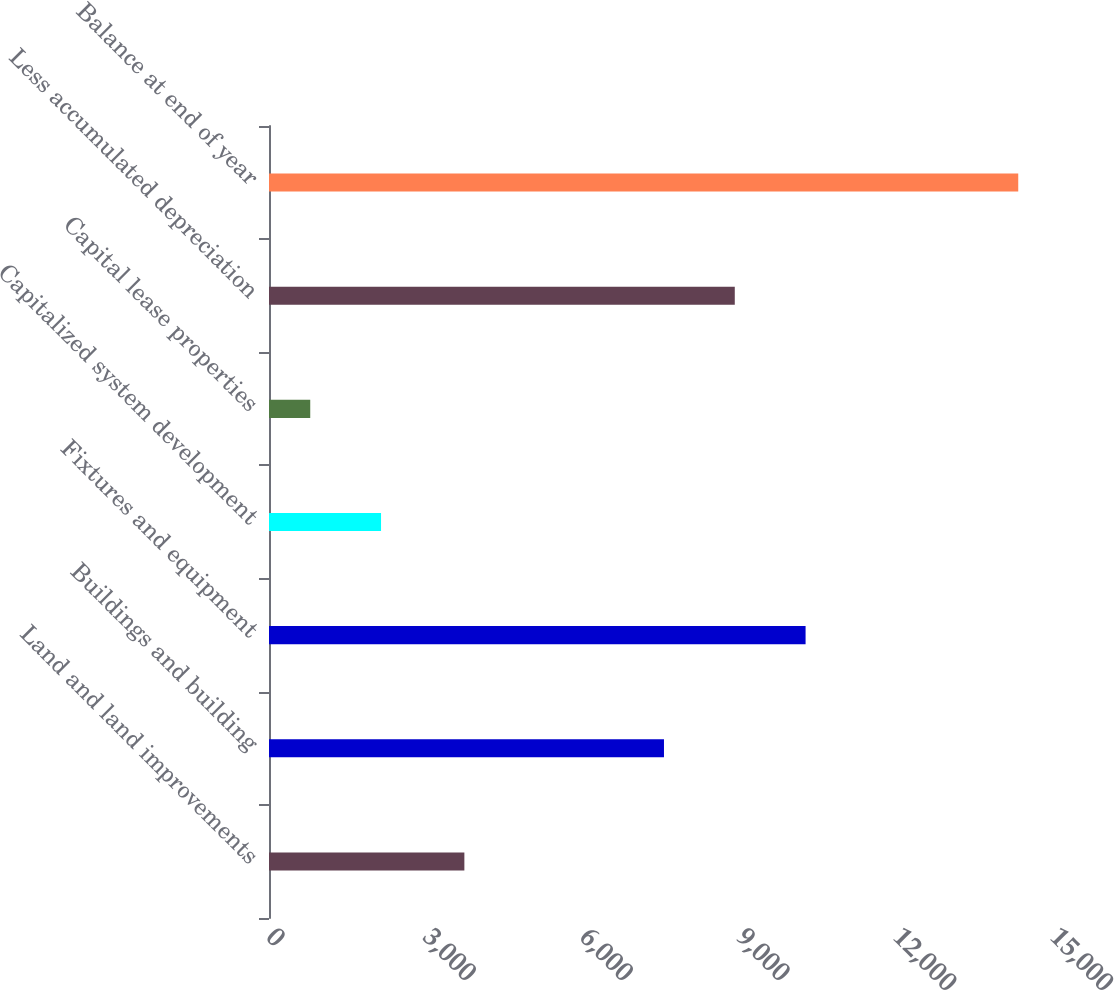Convert chart to OTSL. <chart><loc_0><loc_0><loc_500><loc_500><bar_chart><fcel>Land and land improvements<fcel>Buildings and building<fcel>Fixtures and equipment<fcel>Capitalized system development<fcel>Capital lease properties<fcel>Less accumulated depreciation<fcel>Balance at end of year<nl><fcel>3738<fcel>7557<fcel>10266.2<fcel>2143.6<fcel>789<fcel>8911.6<fcel>14335<nl></chart> 